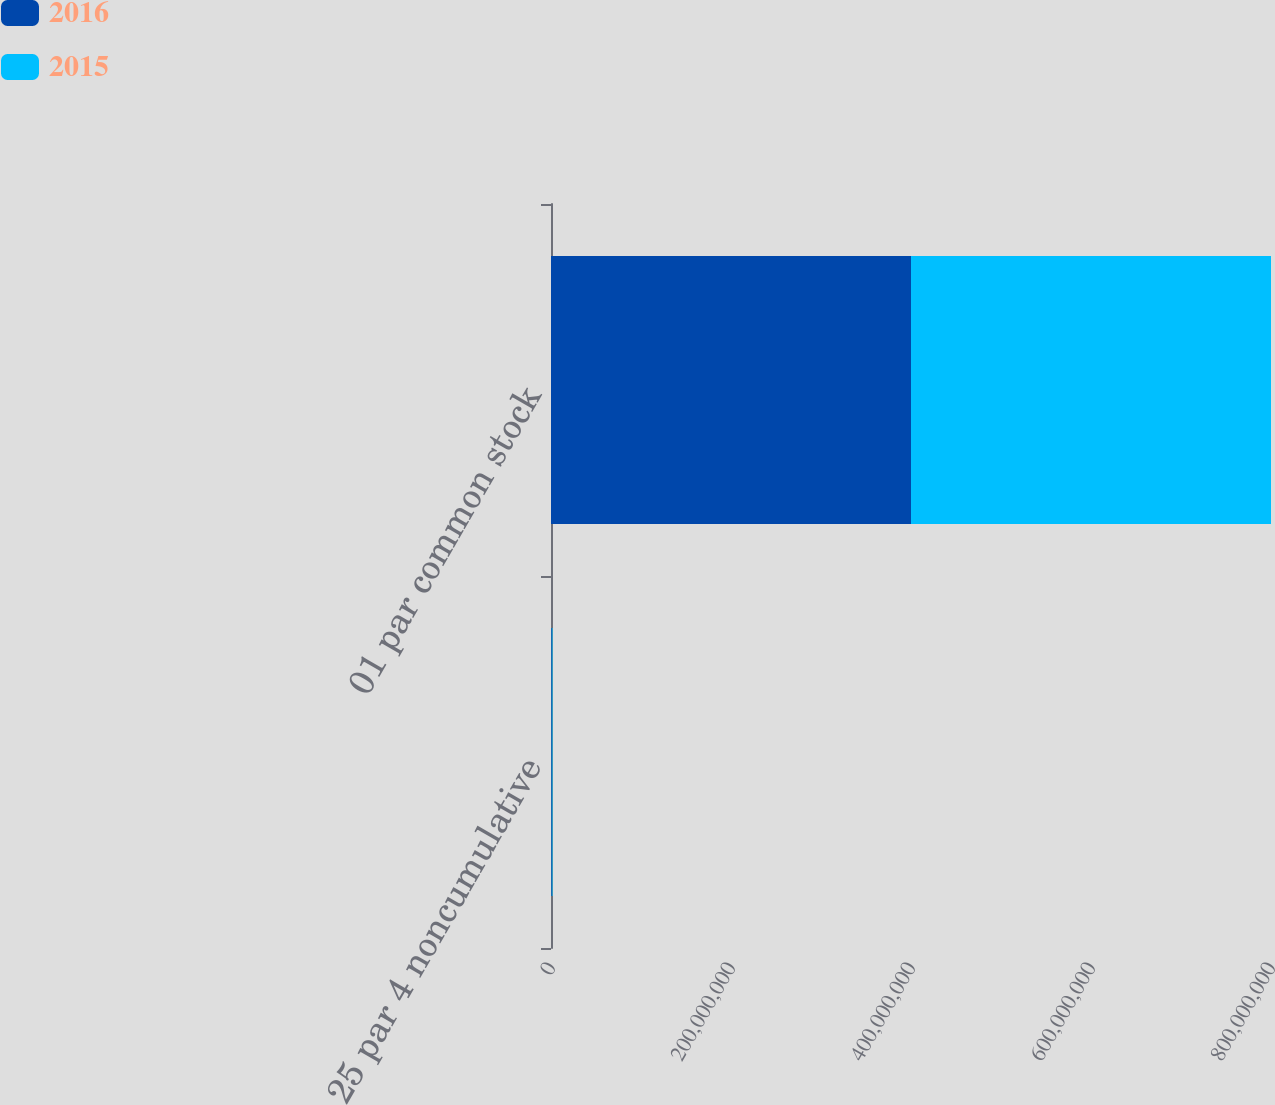<chart> <loc_0><loc_0><loc_500><loc_500><stacked_bar_chart><ecel><fcel>25 par 4 noncumulative<fcel>01 par common stock<nl><fcel>2016<fcel>840000<fcel>4e+08<nl><fcel>2015<fcel>840000<fcel>4e+08<nl></chart> 